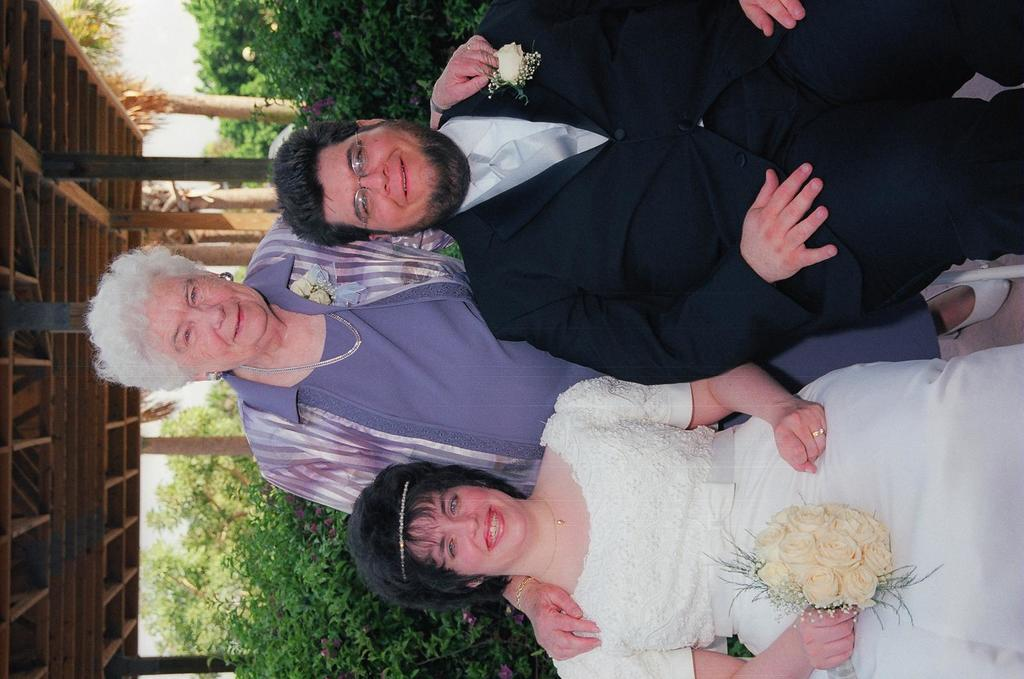How many people are present in the image? There are three people in the image. What expressions do the people have on their faces? The people are wearing smiles on their faces. What can be seen behind the people in the image? There are trees behind the people. What type of structure is visible in the image? There is a shed in the image. What part of the natural environment is visible in the image? The sky is visible in the image. What type of oil is being used by the people in the image? There is no oil present in the image, and the people are not using any oil. What caption would you give to the image? The image does not have a caption, so it's not possible to provide one. 